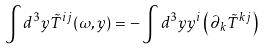<formula> <loc_0><loc_0><loc_500><loc_500>\int d ^ { 3 } y \tilde { T } ^ { i j } ( \omega , { y } ) = - \int d ^ { 3 } y y ^ { i } \left ( \partial _ { k } \tilde { T } ^ { k j } \right )</formula> 